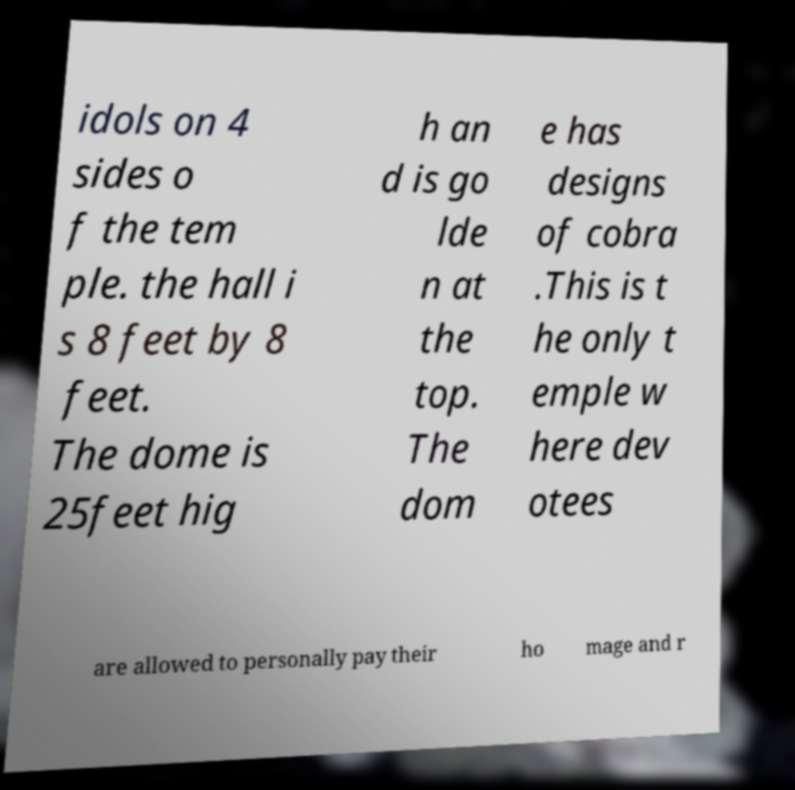Please read and relay the text visible in this image. What does it say? idols on 4 sides o f the tem ple. the hall i s 8 feet by 8 feet. The dome is 25feet hig h an d is go lde n at the top. The dom e has designs of cobra .This is t he only t emple w here dev otees are allowed to personally pay their ho mage and r 